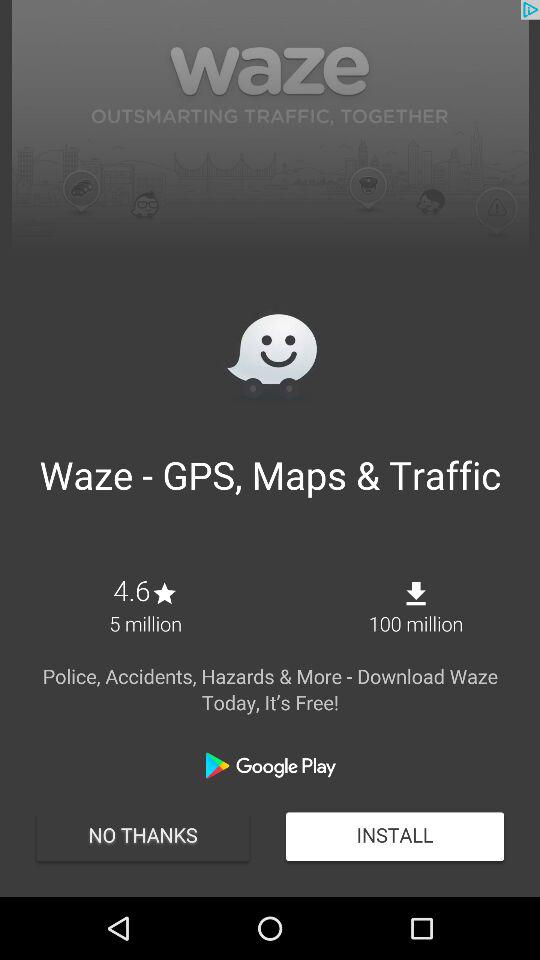How many more downloads does Waze have than reviews?
Answer the question using a single word or phrase. 95 million 